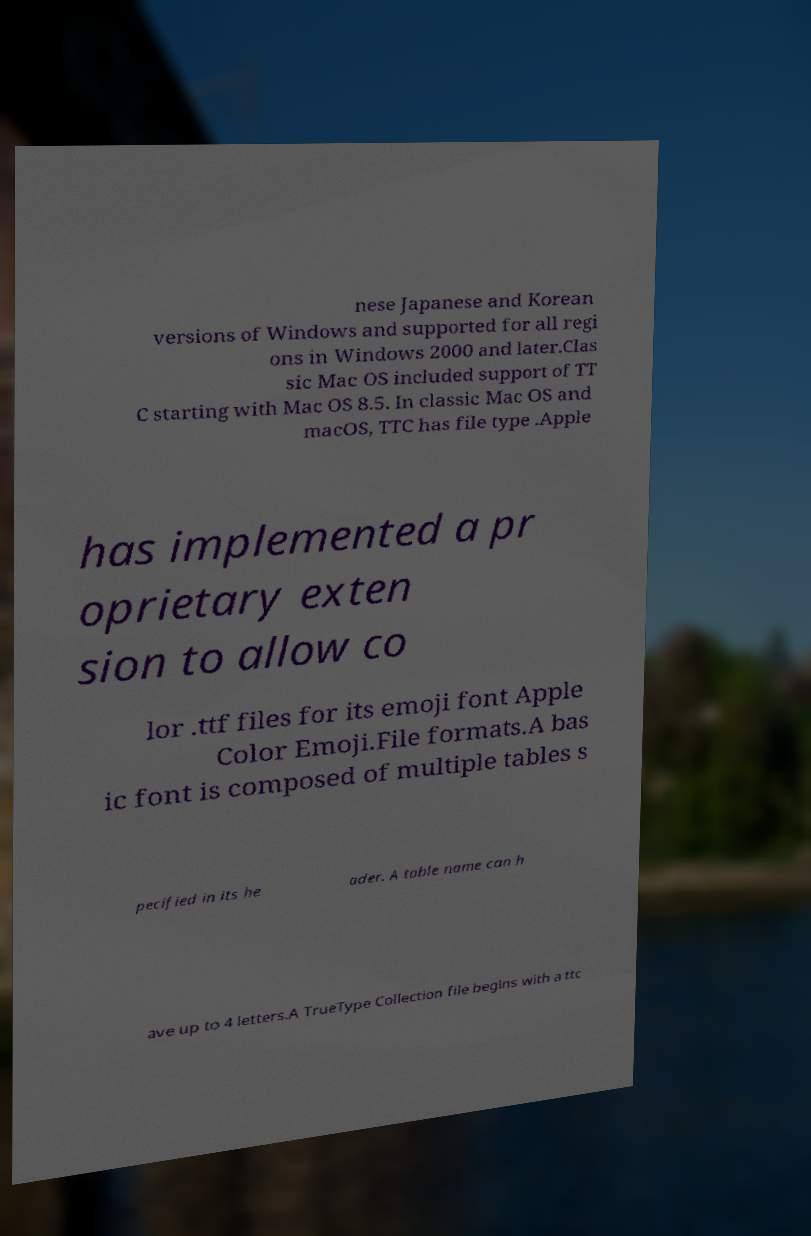What messages or text are displayed in this image? I need them in a readable, typed format. nese Japanese and Korean versions of Windows and supported for all regi ons in Windows 2000 and later.Clas sic Mac OS included support of TT C starting with Mac OS 8.5. In classic Mac OS and macOS, TTC has file type .Apple has implemented a pr oprietary exten sion to allow co lor .ttf files for its emoji font Apple Color Emoji.File formats.A bas ic font is composed of multiple tables s pecified in its he ader. A table name can h ave up to 4 letters.A TrueType Collection file begins with a ttc 